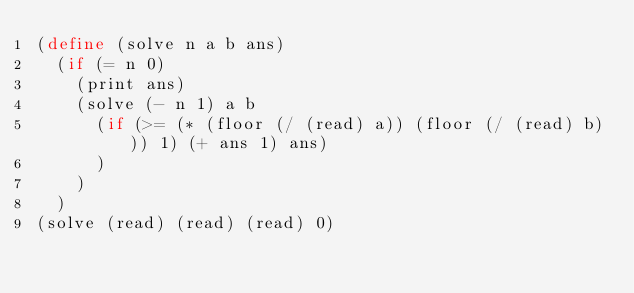<code> <loc_0><loc_0><loc_500><loc_500><_Scheme_>(define (solve n a b ans)
  (if (= n 0)
    (print ans)
    (solve (- n 1) a b
      (if (>= (* (floor (/ (read) a)) (floor (/ (read) b))) 1) (+ ans 1) ans)
      )
    )
  )
(solve (read) (read) (read) 0)</code> 